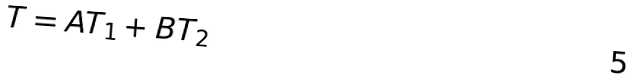<formula> <loc_0><loc_0><loc_500><loc_500>T = A T _ { 1 } + B T _ { 2 }</formula> 